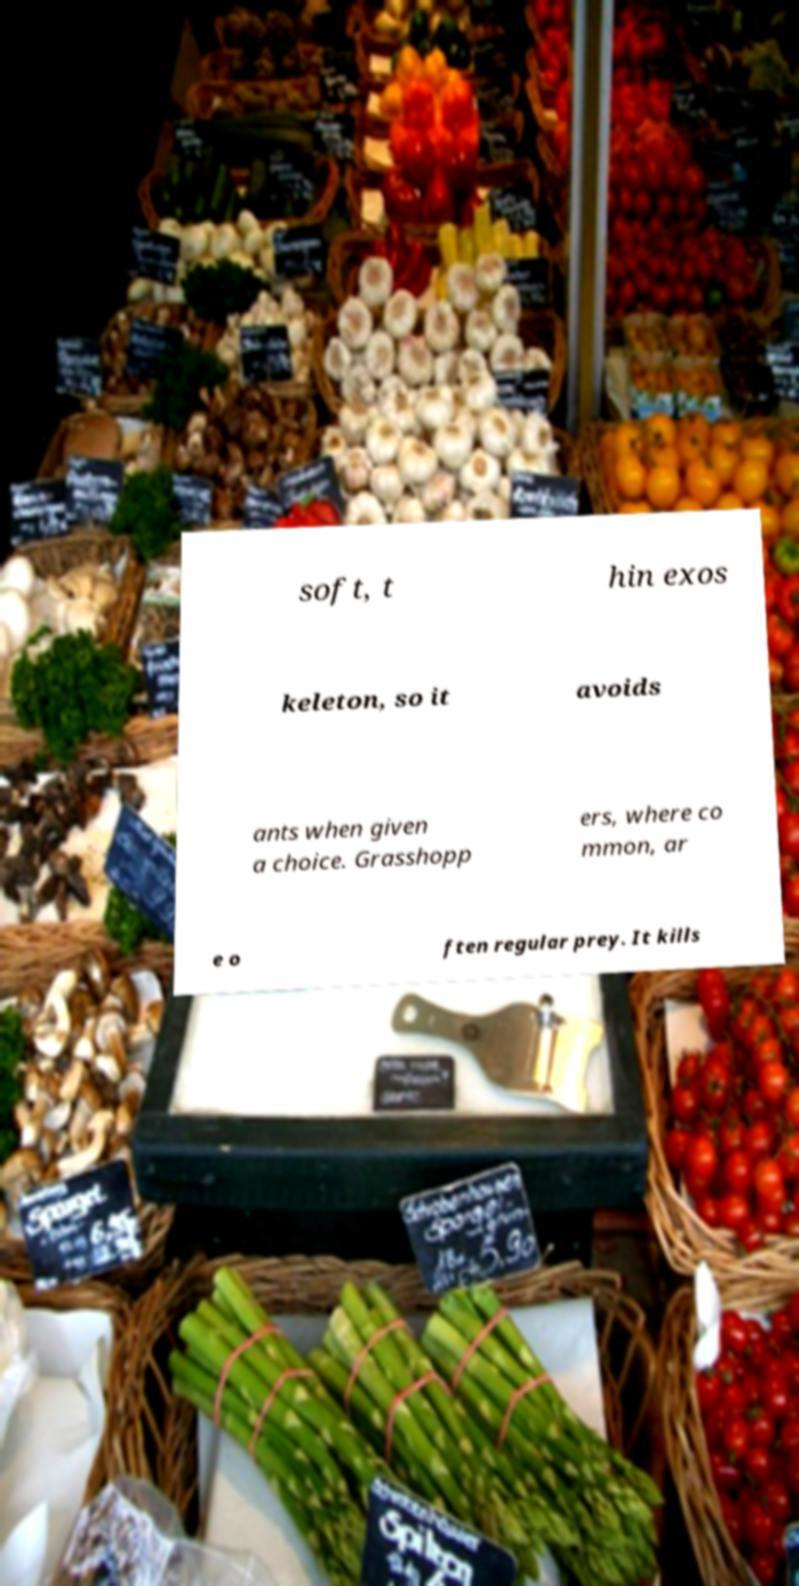There's text embedded in this image that I need extracted. Can you transcribe it verbatim? soft, t hin exos keleton, so it avoids ants when given a choice. Grasshopp ers, where co mmon, ar e o ften regular prey. It kills 